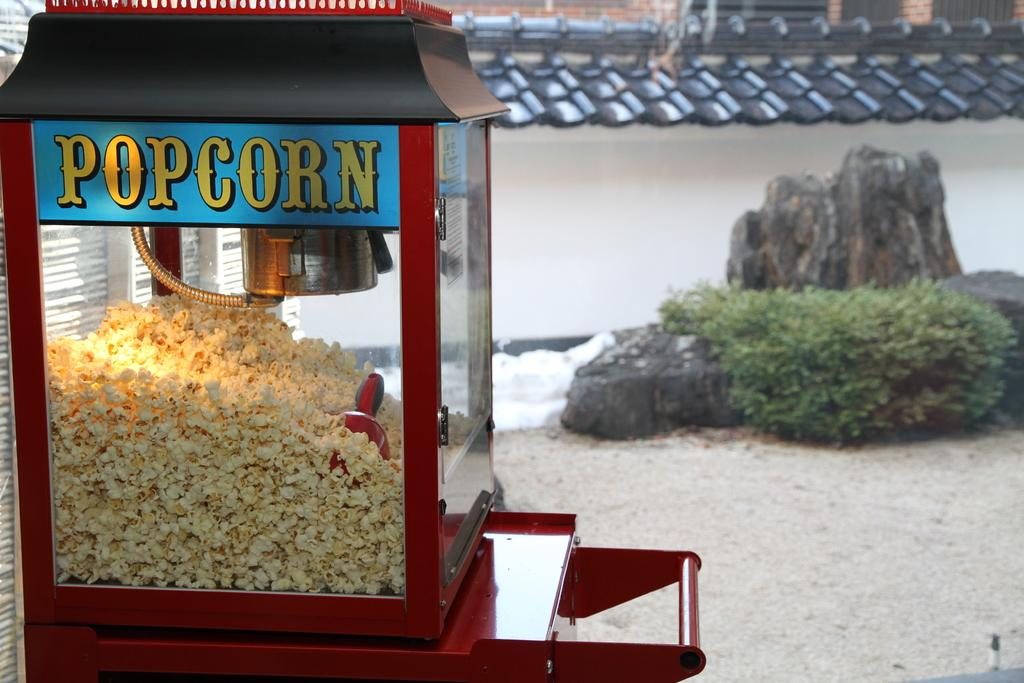Provide a one-sentence caption for the provided image. A large popcorn machine is sitting to the side of a rock and bush. 